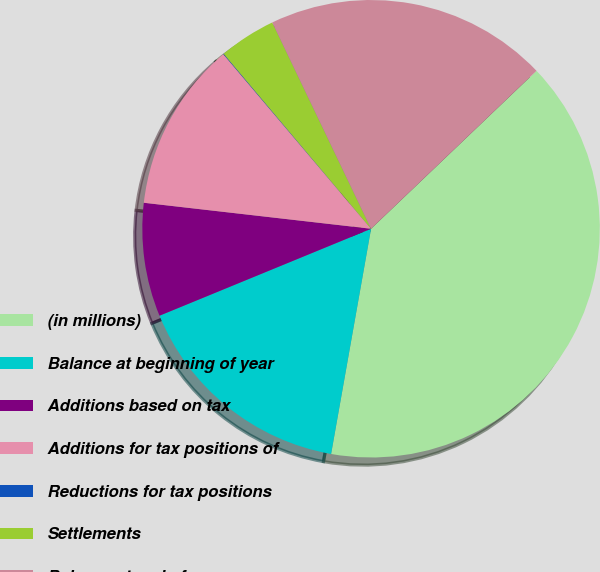<chart> <loc_0><loc_0><loc_500><loc_500><pie_chart><fcel>(in millions)<fcel>Balance at beginning of year<fcel>Additions based on tax<fcel>Additions for tax positions of<fcel>Reductions for tax positions<fcel>Settlements<fcel>Balance at end of year<nl><fcel>39.93%<fcel>16.0%<fcel>8.02%<fcel>12.01%<fcel>0.04%<fcel>4.03%<fcel>19.98%<nl></chart> 